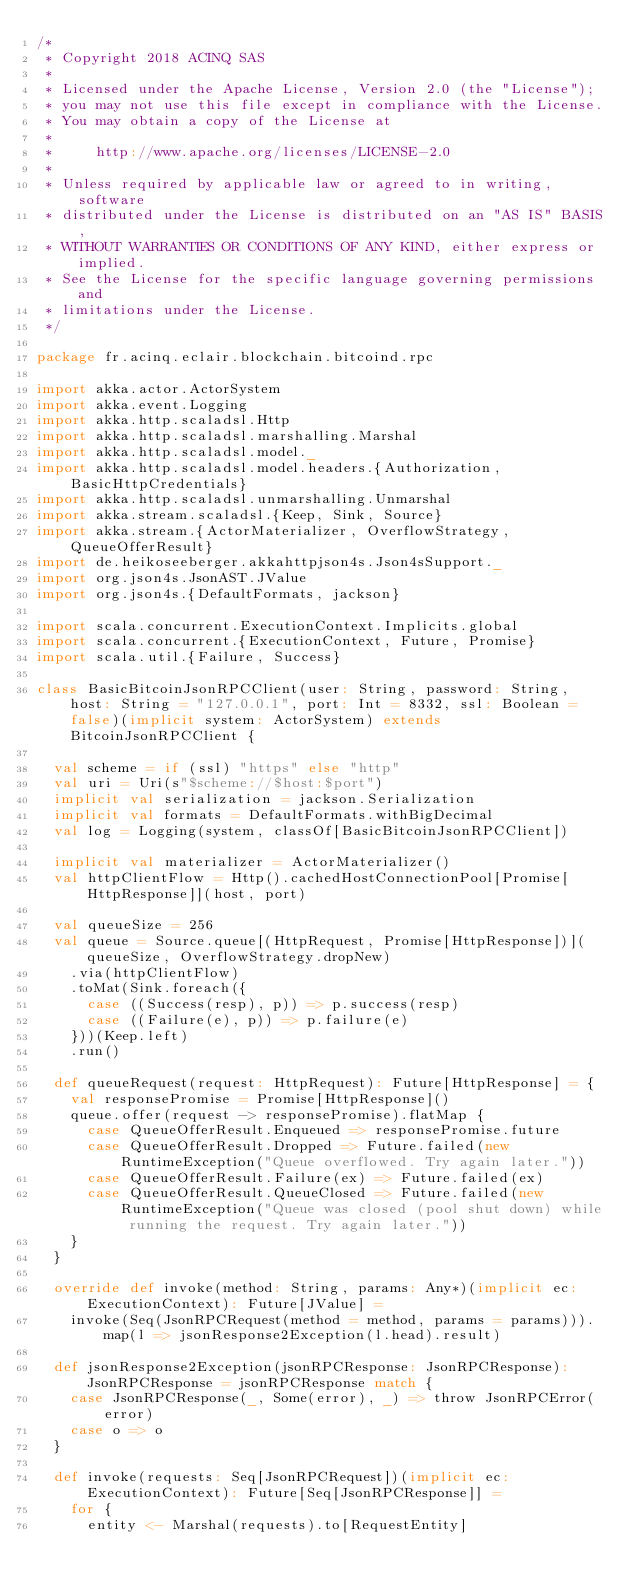Convert code to text. <code><loc_0><loc_0><loc_500><loc_500><_Scala_>/*
 * Copyright 2018 ACINQ SAS
 *
 * Licensed under the Apache License, Version 2.0 (the "License");
 * you may not use this file except in compliance with the License.
 * You may obtain a copy of the License at
 *
 *     http://www.apache.org/licenses/LICENSE-2.0
 *
 * Unless required by applicable law or agreed to in writing, software
 * distributed under the License is distributed on an "AS IS" BASIS,
 * WITHOUT WARRANTIES OR CONDITIONS OF ANY KIND, either express or implied.
 * See the License for the specific language governing permissions and
 * limitations under the License.
 */

package fr.acinq.eclair.blockchain.bitcoind.rpc

import akka.actor.ActorSystem
import akka.event.Logging
import akka.http.scaladsl.Http
import akka.http.scaladsl.marshalling.Marshal
import akka.http.scaladsl.model._
import akka.http.scaladsl.model.headers.{Authorization, BasicHttpCredentials}
import akka.http.scaladsl.unmarshalling.Unmarshal
import akka.stream.scaladsl.{Keep, Sink, Source}
import akka.stream.{ActorMaterializer, OverflowStrategy, QueueOfferResult}
import de.heikoseeberger.akkahttpjson4s.Json4sSupport._
import org.json4s.JsonAST.JValue
import org.json4s.{DefaultFormats, jackson}

import scala.concurrent.ExecutionContext.Implicits.global
import scala.concurrent.{ExecutionContext, Future, Promise}
import scala.util.{Failure, Success}

class BasicBitcoinJsonRPCClient(user: String, password: String, host: String = "127.0.0.1", port: Int = 8332, ssl: Boolean = false)(implicit system: ActorSystem) extends BitcoinJsonRPCClient {

  val scheme = if (ssl) "https" else "http"
  val uri = Uri(s"$scheme://$host:$port")
  implicit val serialization = jackson.Serialization
  implicit val formats = DefaultFormats.withBigDecimal
  val log = Logging(system, classOf[BasicBitcoinJsonRPCClient])

  implicit val materializer = ActorMaterializer()
  val httpClientFlow = Http().cachedHostConnectionPool[Promise[HttpResponse]](host, port)

  val queueSize = 256
  val queue = Source.queue[(HttpRequest, Promise[HttpResponse])](queueSize, OverflowStrategy.dropNew)
    .via(httpClientFlow)
    .toMat(Sink.foreach({
      case ((Success(resp), p)) => p.success(resp)
      case ((Failure(e), p)) => p.failure(e)
    }))(Keep.left)
    .run()

  def queueRequest(request: HttpRequest): Future[HttpResponse] = {
    val responsePromise = Promise[HttpResponse]()
    queue.offer(request -> responsePromise).flatMap {
      case QueueOfferResult.Enqueued => responsePromise.future
      case QueueOfferResult.Dropped => Future.failed(new RuntimeException("Queue overflowed. Try again later."))
      case QueueOfferResult.Failure(ex) => Future.failed(ex)
      case QueueOfferResult.QueueClosed => Future.failed(new RuntimeException("Queue was closed (pool shut down) while running the request. Try again later."))
    }
  }

  override def invoke(method: String, params: Any*)(implicit ec: ExecutionContext): Future[JValue] =
    invoke(Seq(JsonRPCRequest(method = method, params = params))).map(l => jsonResponse2Exception(l.head).result)

  def jsonResponse2Exception(jsonRPCResponse: JsonRPCResponse): JsonRPCResponse = jsonRPCResponse match {
    case JsonRPCResponse(_, Some(error), _) => throw JsonRPCError(error)
    case o => o
  }

  def invoke(requests: Seq[JsonRPCRequest])(implicit ec: ExecutionContext): Future[Seq[JsonRPCResponse]] =
    for {
      entity <- Marshal(requests).to[RequestEntity]</code> 